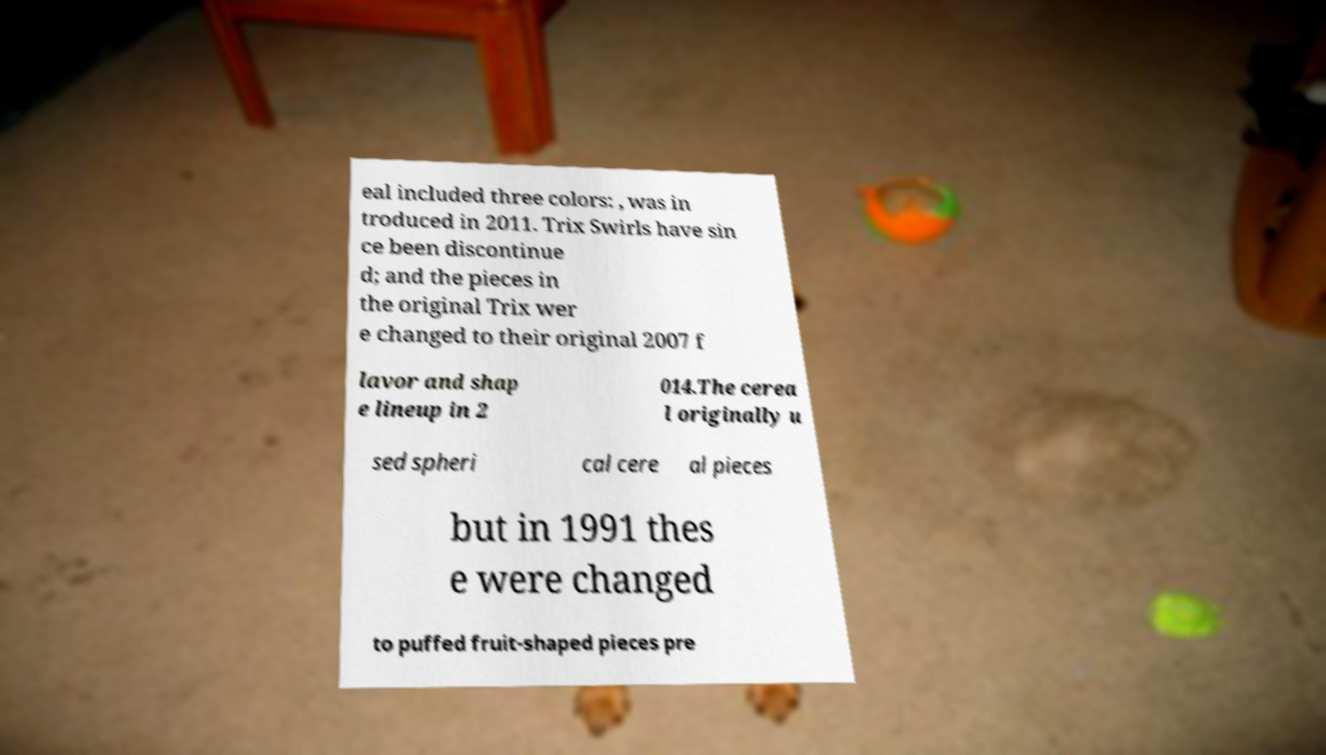There's text embedded in this image that I need extracted. Can you transcribe it verbatim? eal included three colors: , was in troduced in 2011. Trix Swirls have sin ce been discontinue d; and the pieces in the original Trix wer e changed to their original 2007 f lavor and shap e lineup in 2 014.The cerea l originally u sed spheri cal cere al pieces but in 1991 thes e were changed to puffed fruit-shaped pieces pre 